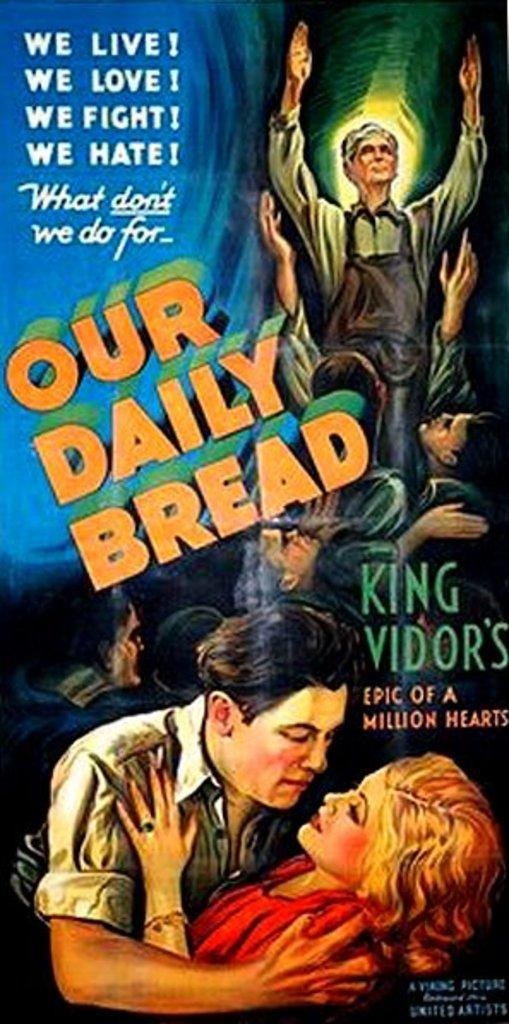<image>
Summarize the visual content of the image. A poster with two people in an embrace with OUR DAILY BREAD on it. 